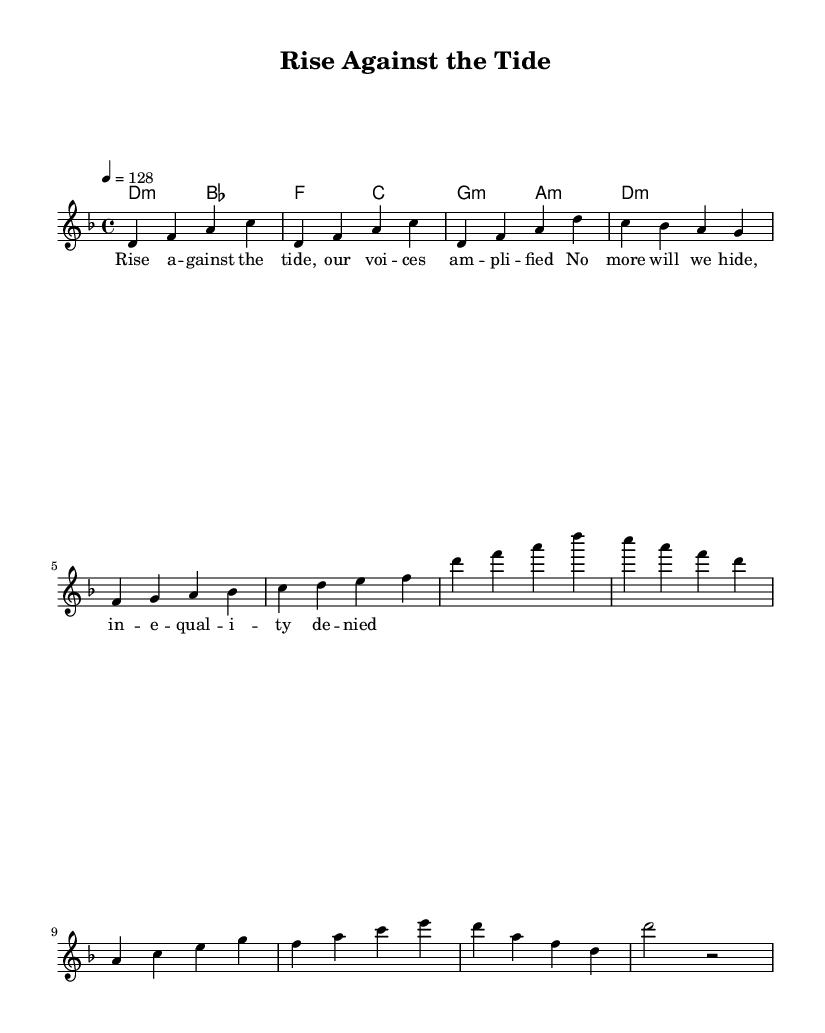What is the key signature of this music? The key signature is D minor, which has one flat. You can identify it by looking for the key signature indicated at the beginning of the staff prior to the first note.
Answer: D minor What is the time signature of this piece? The time signature is 4/4, which is indicated at the beginning of the score next to the key signature. It tells us that there are four beats in each measure.
Answer: 4/4 What is the tempo marking for this piece? The tempo marking is 128 beats per minute. This is specified above the staff in the tempo instruction, showing how fast the piece should be played.
Answer: 128 How many measures are there in the melody section? The melody section provided has a total of 10 measures. Counting all the bar lines in the melody part, we see there are 10 distinct measures.
Answer: 10 In which section does the lyrics mention "our voices amplified"? The lyrics mentioning "our voices amplified" are found in the chorus section, which is identified by the structure of the song and where the dynamics and message peak.
Answer: Chorus What type of accompaniment is used for the melody? The accompaniment used is chordal, as indicated by the chord names written above the staff, showing harmonic support for the melody.
Answer: Chordal What is the last note of the melody before it concludes? The last note of the melody is a D, as seen in the final measure where the melody ends on the note D before going into a rest.
Answer: D 